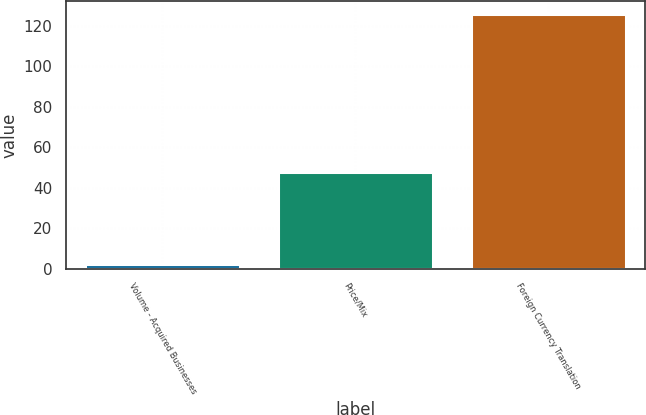<chart> <loc_0><loc_0><loc_500><loc_500><bar_chart><fcel>Volume - Acquired Businesses<fcel>Price/Mix<fcel>Foreign Currency Translation<nl><fcel>2.4<fcel>47.9<fcel>125.7<nl></chart> 